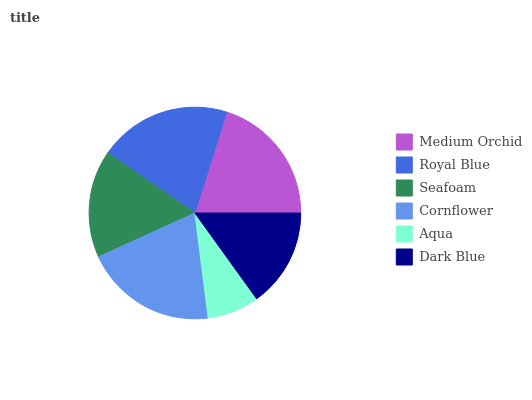Is Aqua the minimum?
Answer yes or no. Yes. Is Royal Blue the maximum?
Answer yes or no. Yes. Is Seafoam the minimum?
Answer yes or no. No. Is Seafoam the maximum?
Answer yes or no. No. Is Royal Blue greater than Seafoam?
Answer yes or no. Yes. Is Seafoam less than Royal Blue?
Answer yes or no. Yes. Is Seafoam greater than Royal Blue?
Answer yes or no. No. Is Royal Blue less than Seafoam?
Answer yes or no. No. Is Medium Orchid the high median?
Answer yes or no. Yes. Is Seafoam the low median?
Answer yes or no. Yes. Is Cornflower the high median?
Answer yes or no. No. Is Royal Blue the low median?
Answer yes or no. No. 